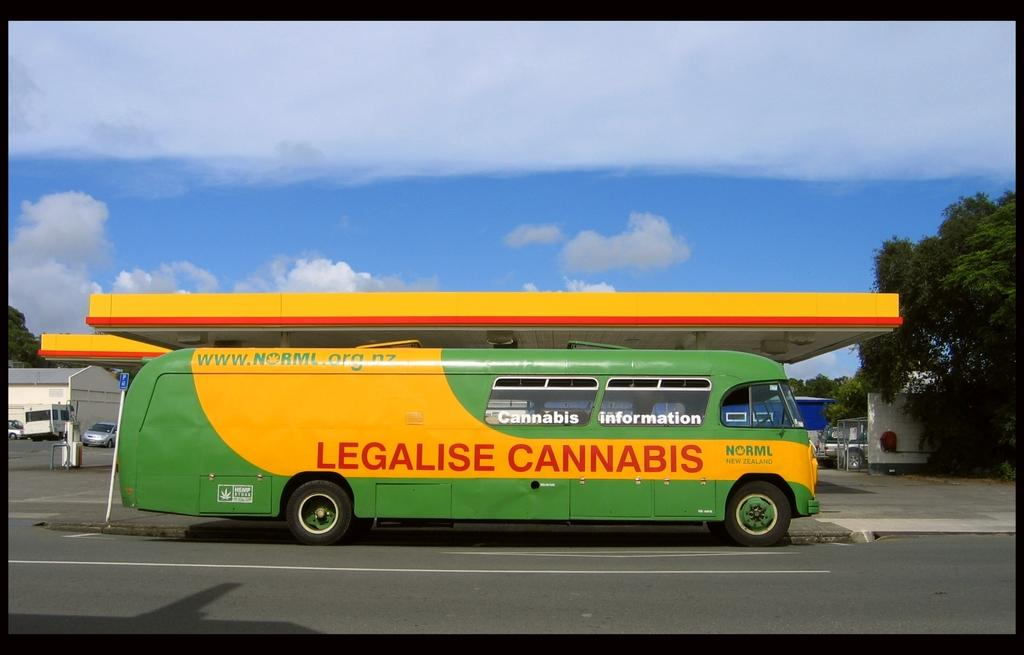What can be seen on the road in the image? There are vehicles on the road in the image. What structure is visible in the image? There is a building in the image. What type of vegetation is present in the image? There are trees in the image. What else can be seen in the image besides the vehicles, building, and trees? There are some objects in the image. What is visible in the background of the image? The sky is visible in the background of the image. What can be observed in the sky? Clouds are present in the sky. Can you see the ocean in the image? No, the ocean is not present in the image. What type of feather can be seen on the building in the image? There are no feathers visible on the building or anywhere else in the image. 